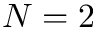<formula> <loc_0><loc_0><loc_500><loc_500>N = 2</formula> 